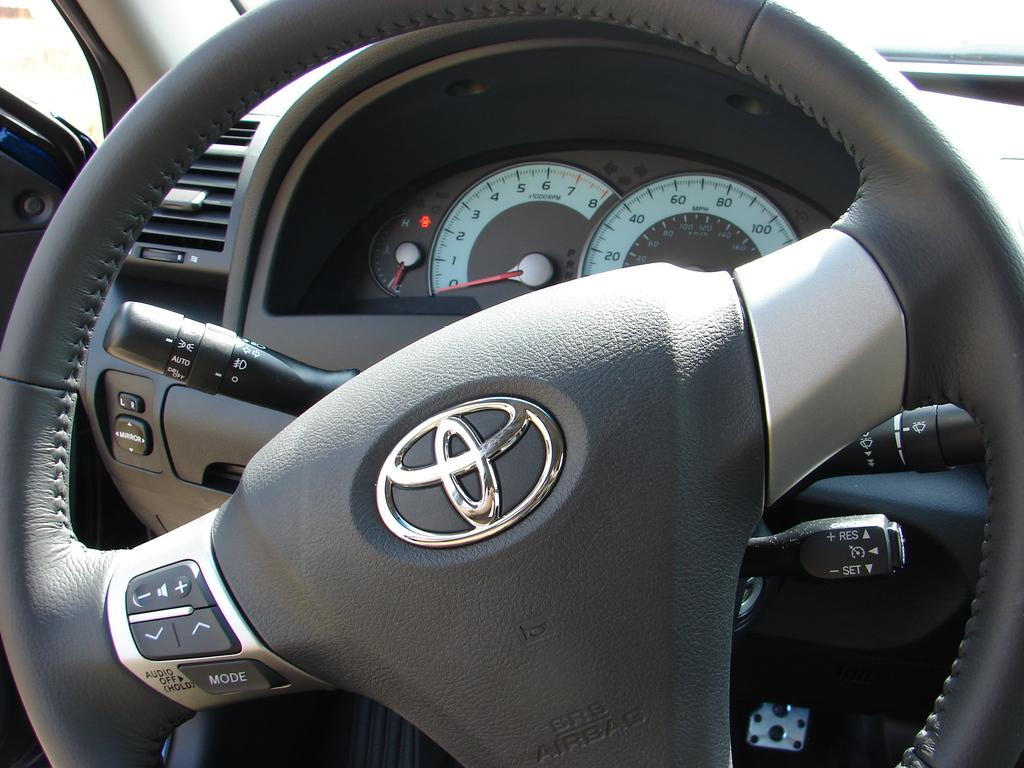What is the main object in the image? The main object in the image is a steering wheel. What other instrument is present in the image? There is a speedometer present in the image. Are there any labels or writings in the image? Yes, there are writings in multiple places in the image. What type of surprise can be seen in the image? There is no surprise present in the image; it contains a steering wheel, a speedometer, and writings. How many oranges are visible in the image? There are no oranges present in the image. 